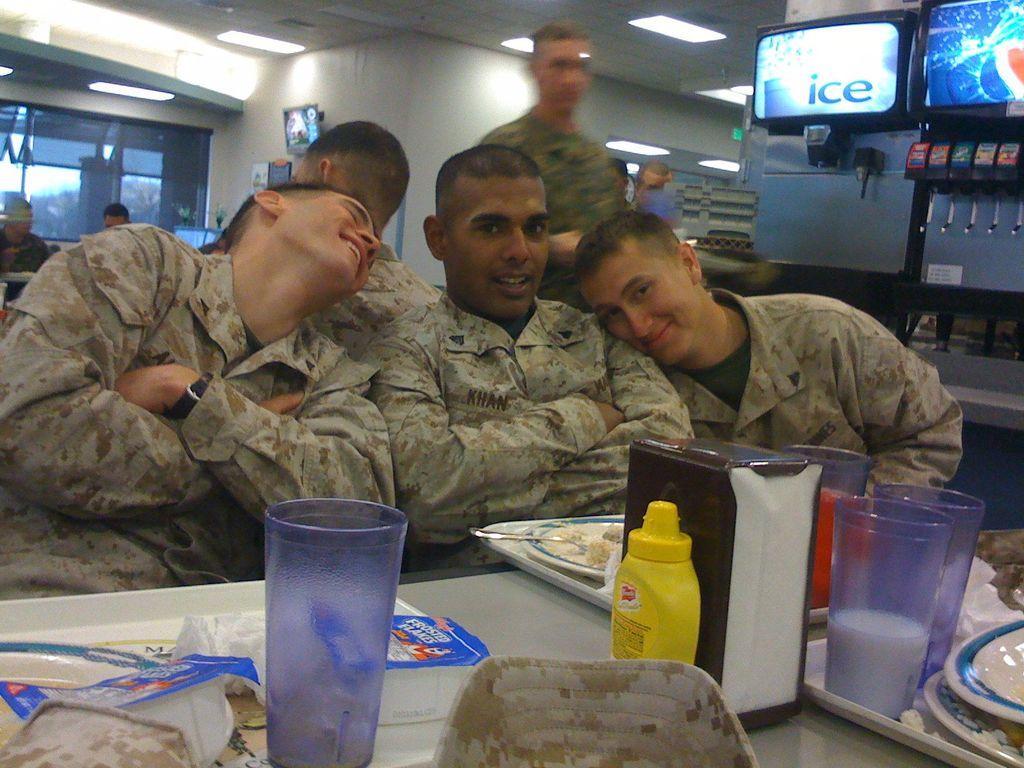Can you describe this image briefly? Few people sitting and this man standing,in front of these people we can see glasses,trays,plates,food and objects on the table. In the background we can see wall,people and glass window. Right side of the image we can see machines. 